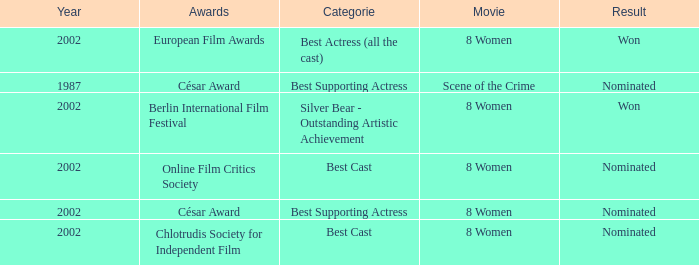What was the categorie in 2002 at the Berlin international Film Festival that Danielle Darrieux was in? Silver Bear - Outstanding Artistic Achievement. Could you help me parse every detail presented in this table? {'header': ['Year', 'Awards', 'Categorie', 'Movie', 'Result'], 'rows': [['2002', 'European Film Awards', 'Best Actress (all the cast)', '8 Women', 'Won'], ['1987', 'César Award', 'Best Supporting Actress', 'Scene of the Crime', 'Nominated'], ['2002', 'Berlin International Film Festival', 'Silver Bear - Outstanding Artistic Achievement', '8 Women', 'Won'], ['2002', 'Online Film Critics Society', 'Best Cast', '8 Women', 'Nominated'], ['2002', 'César Award', 'Best Supporting Actress', '8 Women', 'Nominated'], ['2002', 'Chlotrudis Society for Independent Film', 'Best Cast', '8 Women', 'Nominated']]} 